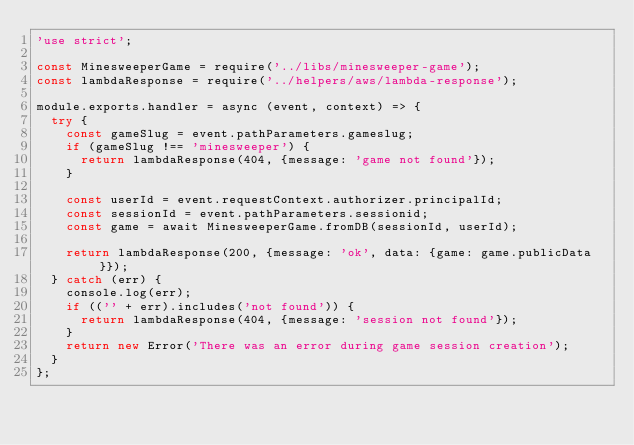Convert code to text. <code><loc_0><loc_0><loc_500><loc_500><_JavaScript_>'use strict';

const MinesweeperGame = require('../libs/minesweeper-game');
const lambdaResponse = require('../helpers/aws/lambda-response');

module.exports.handler = async (event, context) => {
  try {
    const gameSlug = event.pathParameters.gameslug;
    if (gameSlug !== 'minesweeper') {
      return lambdaResponse(404, {message: 'game not found'});
    }

    const userId = event.requestContext.authorizer.principalId;
    const sessionId = event.pathParameters.sessionid;
    const game = await MinesweeperGame.fromDB(sessionId, userId);

    return lambdaResponse(200, {message: 'ok', data: {game: game.publicData}});
  } catch (err) {
    console.log(err);
    if (('' + err).includes('not found')) {
      return lambdaResponse(404, {message: 'session not found'});
    }
    return new Error('There was an error during game session creation');
  }
};
</code> 